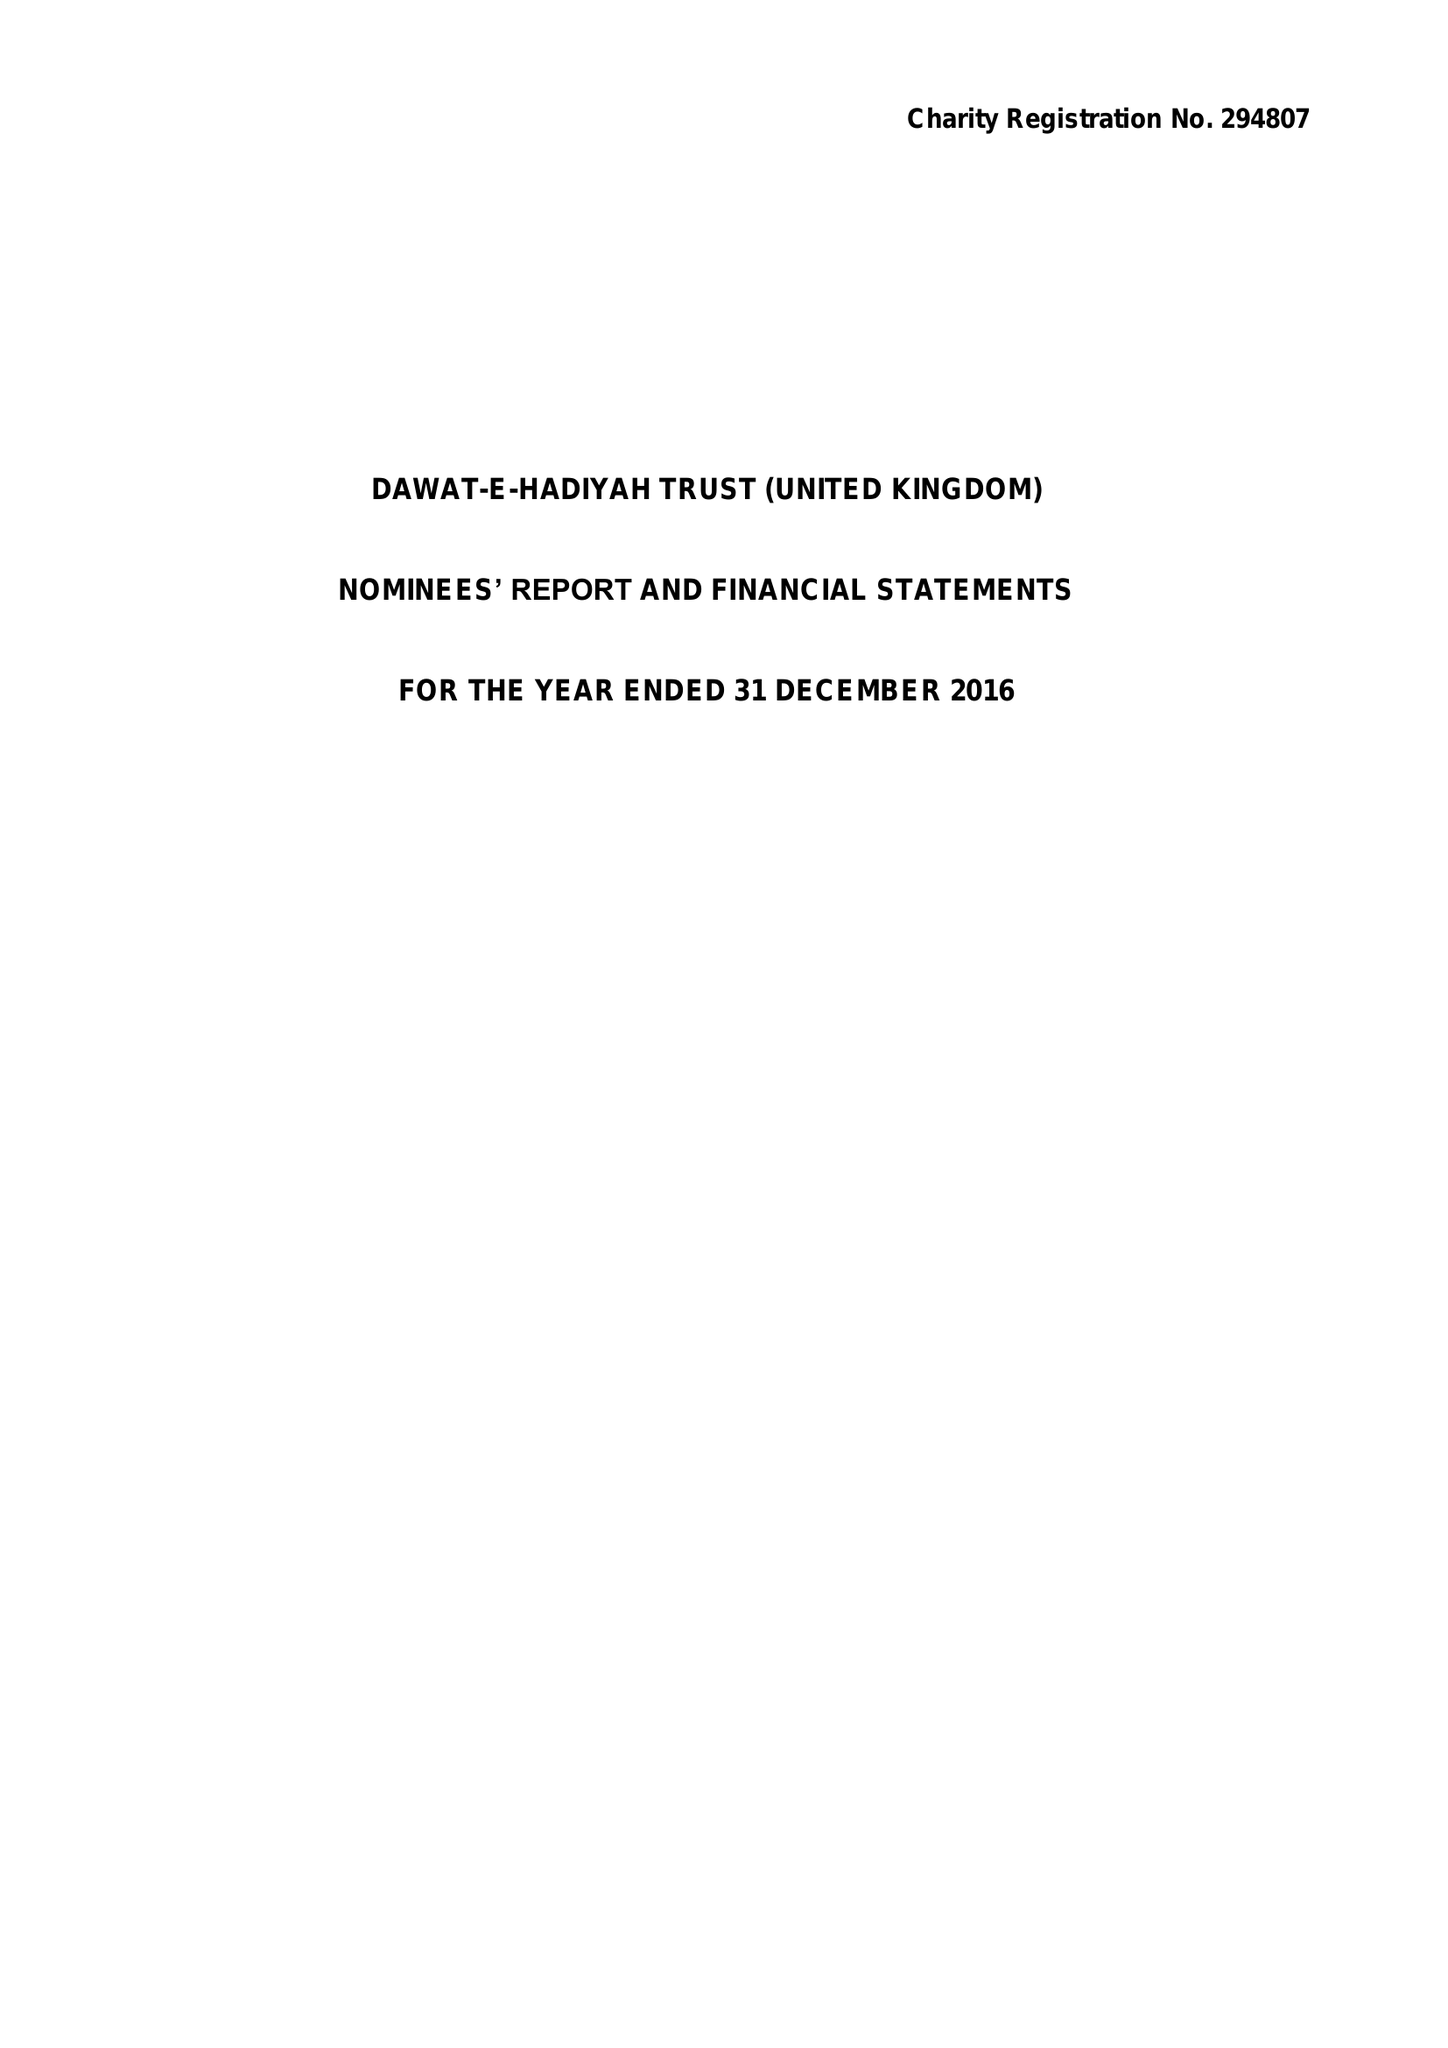What is the value for the charity_name?
Answer the question using a single word or phrase. Dawat-E-Hadiyah Trust (United Kingdom) 